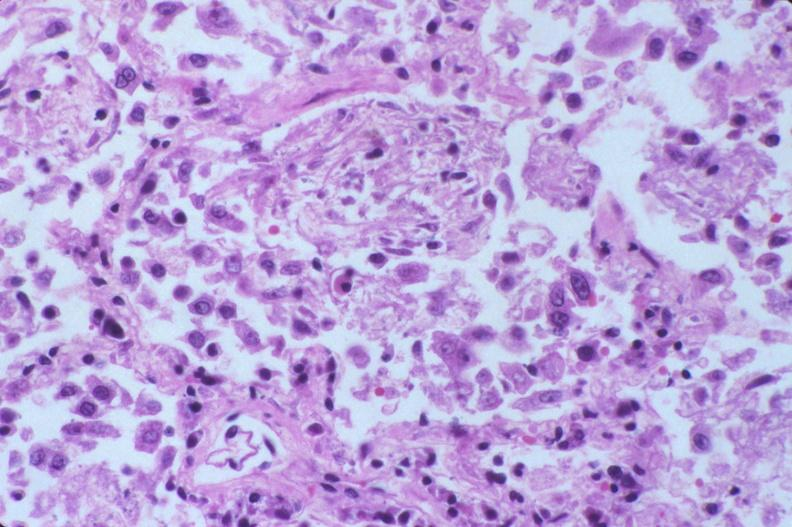does male reproductive show lung, diffuse alveolar damage?
Answer the question using a single word or phrase. No 